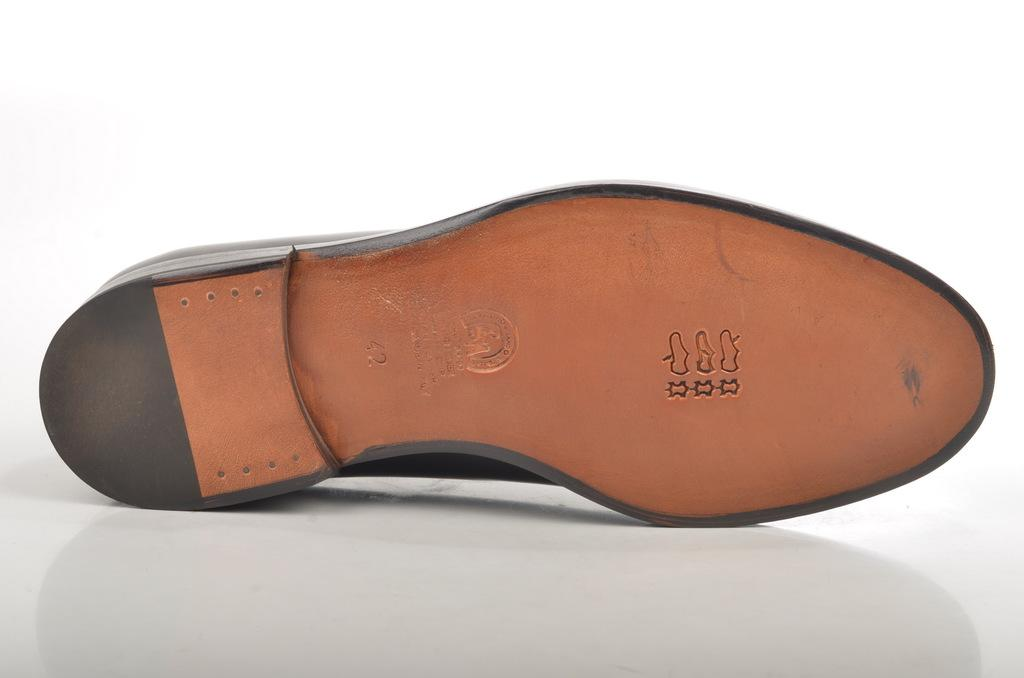What object is placed on the white surface in the image? There is a shoe on a white surface in the image. What color is the background of the image? The background of the image is white. Where is the beam located in the image? There is no beam present in the image. What type of yoke can be seen in the image? There is no yoke present in the image. 